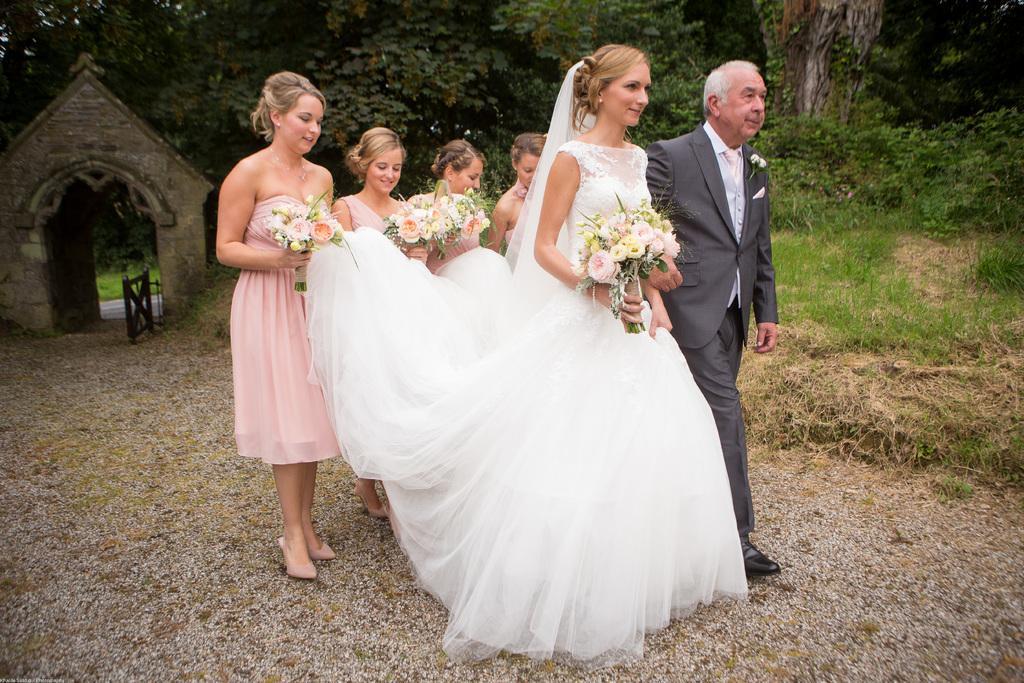How would you summarize this image in a sentence or two? There are four persons in pink color dresses holding flower buckeyes and edges of a white color dress of a woman who is holding a flower buckeye and walking on the road along with a person who is in suit. In the background, there is a gate, there is grass and there are plants and trees on the ground. 